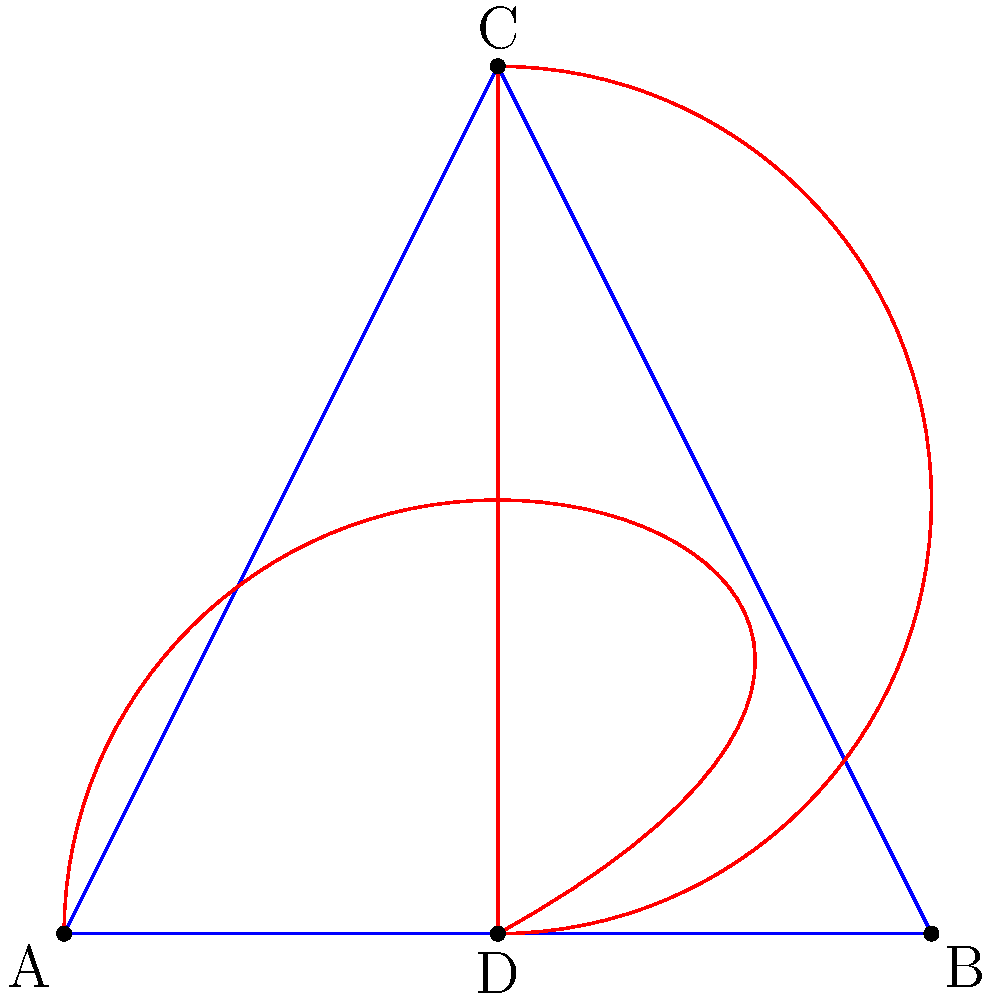A magical heart-shaped jewel is inscribed in a triangle ABC as shown in the figure. If the triangle undergoes a dilation with scale factor $k=2$ centered at point A, what will be the ratio of the area of the transformed heart to the original heart? To solve this problem, let's follow these steps:

1) In a dilation with scale factor $k$, lengths are multiplied by $k$, while areas are multiplied by $k^2$.

2) The dilation is centered at point A, which means:
   - Point A remains fixed
   - The distances AB and AC will double
   - The height of the triangle (from A to BC) will double

3) The heart is inscribed in the triangle, so it will undergo the same transformation as the triangle.

4) Since the dilation has a scale factor of $k=2$, the area of the transformed heart will be $2^2 = 4$ times the area of the original heart.

5) The ratio of the area of the transformed heart to the original heart is therefore 4:1.
Answer: 4:1 